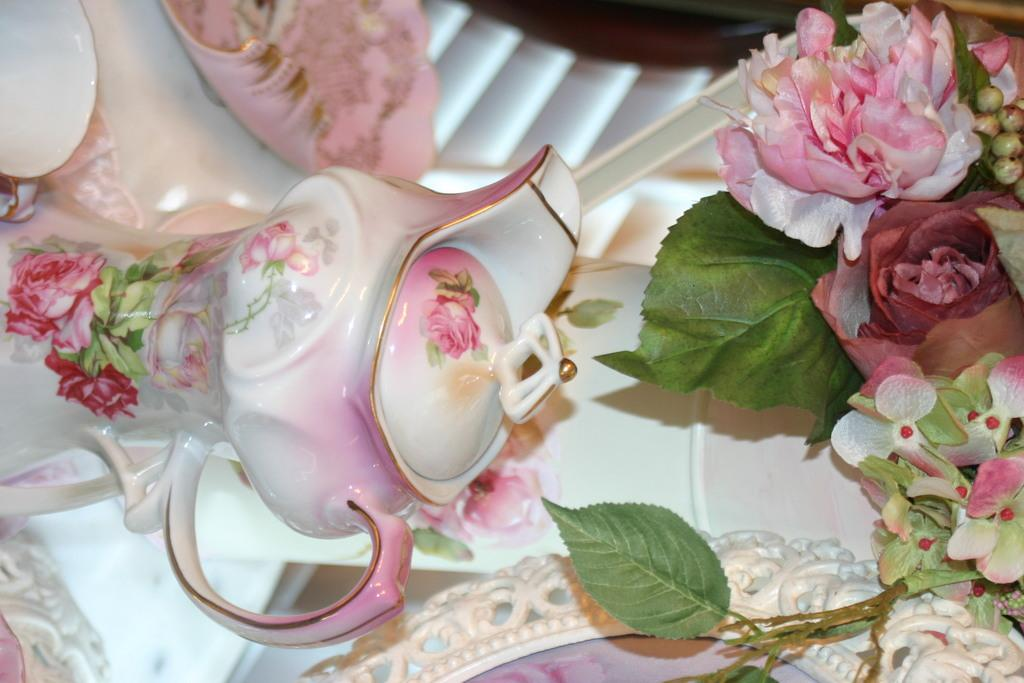What is in the pot that is visible in the image? There is a flower in the pot. Where is the pot and flower located in the image? The pot and flower are on a table. What else can be seen on the right side of the image? There are flowers on the right side of the image. What other plant parts are visible in the image? There are leaves visible in the image. How does the flower fight against the leaves in the image? The flower does not fight against the leaves in the image; they are both part of the same plant and coexist peacefully. 